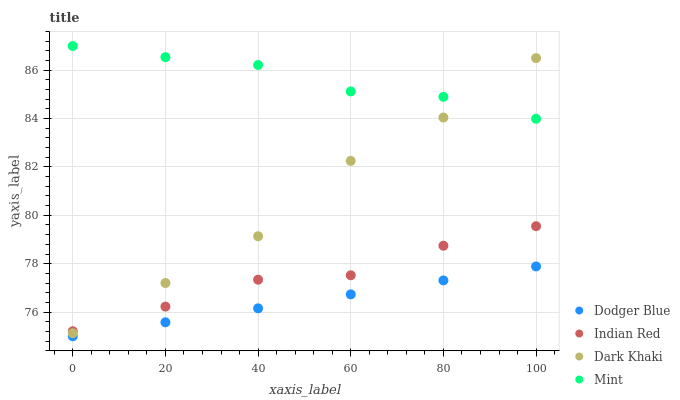Does Dodger Blue have the minimum area under the curve?
Answer yes or no. Yes. Does Mint have the maximum area under the curve?
Answer yes or no. Yes. Does Mint have the minimum area under the curve?
Answer yes or no. No. Does Dodger Blue have the maximum area under the curve?
Answer yes or no. No. Is Dodger Blue the smoothest?
Answer yes or no. Yes. Is Dark Khaki the roughest?
Answer yes or no. Yes. Is Mint the smoothest?
Answer yes or no. No. Is Mint the roughest?
Answer yes or no. No. Does Dodger Blue have the lowest value?
Answer yes or no. Yes. Does Mint have the lowest value?
Answer yes or no. No. Does Mint have the highest value?
Answer yes or no. Yes. Does Dodger Blue have the highest value?
Answer yes or no. No. Is Dodger Blue less than Indian Red?
Answer yes or no. Yes. Is Mint greater than Indian Red?
Answer yes or no. Yes. Does Indian Red intersect Dark Khaki?
Answer yes or no. Yes. Is Indian Red less than Dark Khaki?
Answer yes or no. No. Is Indian Red greater than Dark Khaki?
Answer yes or no. No. Does Dodger Blue intersect Indian Red?
Answer yes or no. No. 